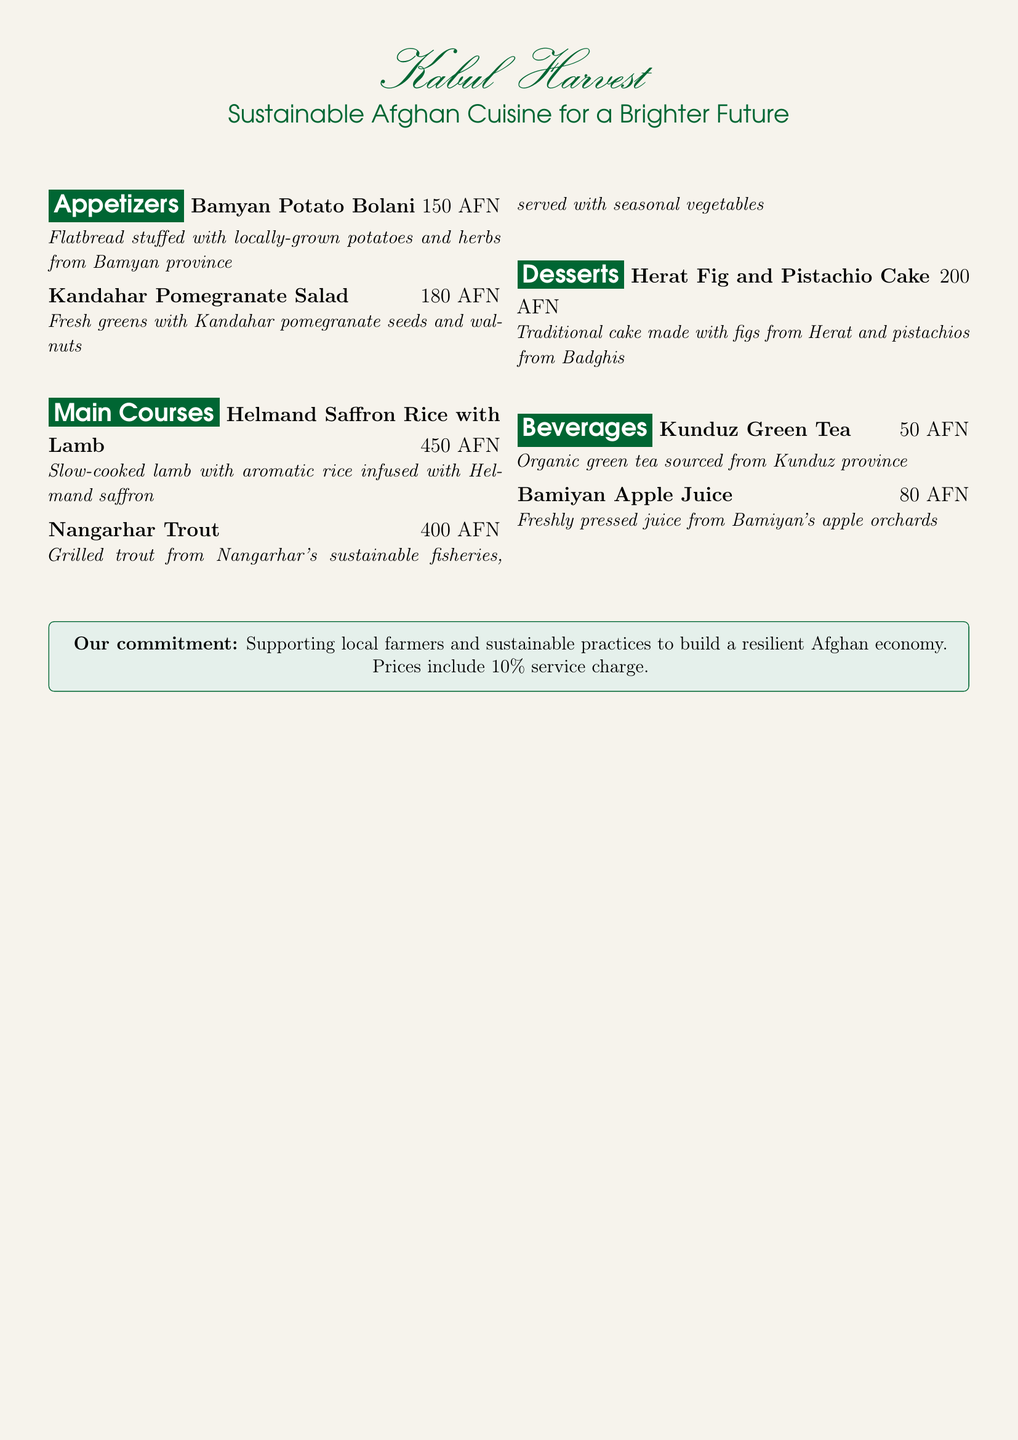What is the name of the restaurant? The restaurant's name is prominently featured at the top of the menu.
Answer: Kabul Harvest What is the price of the Kandahar Pomegranate Salad? The price is listed next to the dish in the menu.
Answer: 180 AFN Which province is the apple juice sourced from? The province is mentioned in the beverage section of the menu.
Answer: Bamiyan How many appetizers are listed on the menu? The number of appetizers can be counted from the appetizers section.
Answer: 2 What is the main ingredient in the Herat Fig and Pistachio Cake? The main ingredients are specified in the dessert description.
Answer: Figs and pistachios What commitment does the restaurant emphasize? The commitment is stated in the box at the bottom of the menu.
Answer: Supporting local farmers How much is the service charge included in prices? The service charge percentage is mentioned in the commitment section.
Answer: 10% What type of tea is offered in the beverages? The type of tea is specified in the beverages section of the menu.
Answer: Green tea Which dish contains lamb? The specific dish name can be directly found in the main courses section.
Answer: Helmand Saffron Rice with Lamb 